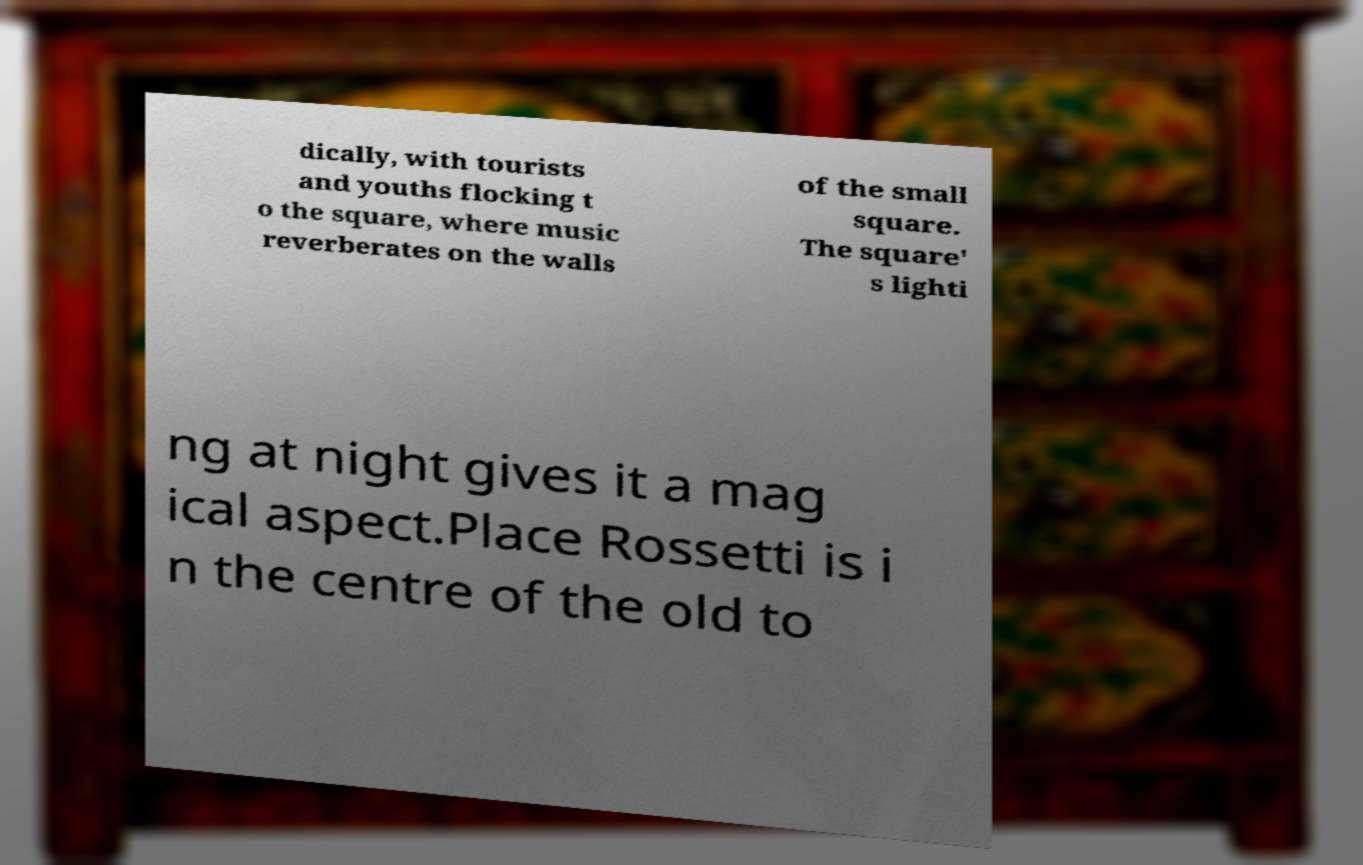Could you assist in decoding the text presented in this image and type it out clearly? dically, with tourists and youths flocking t o the square, where music reverberates on the walls of the small square. The square' s lighti ng at night gives it a mag ical aspect.Place Rossetti is i n the centre of the old to 